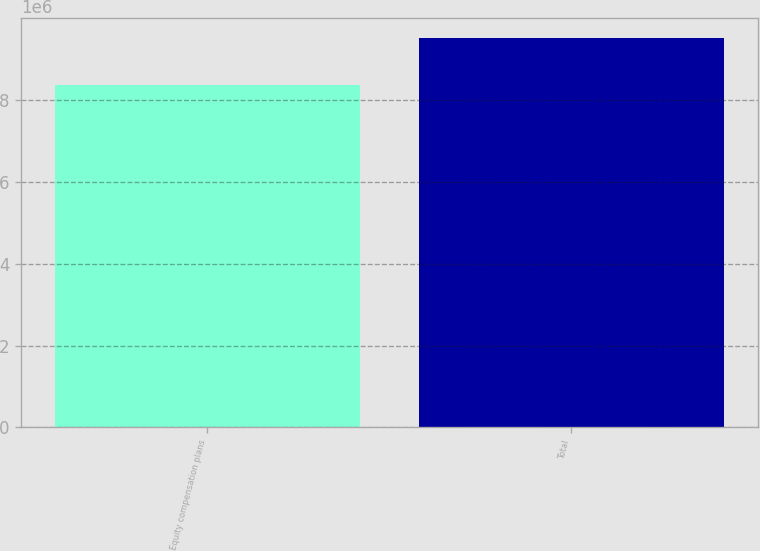Convert chart to OTSL. <chart><loc_0><loc_0><loc_500><loc_500><bar_chart><fcel>Equity compensation plans<fcel>Total<nl><fcel>8.37373e+06<fcel>9.51908e+06<nl></chart> 